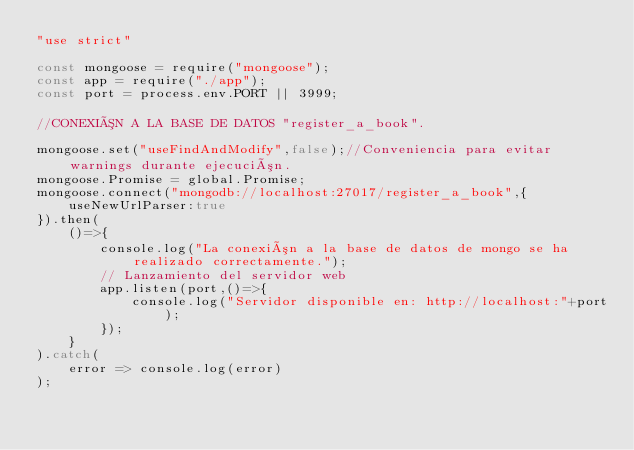Convert code to text. <code><loc_0><loc_0><loc_500><loc_500><_JavaScript_>"use strict"

const mongoose = require("mongoose");
const app = require("./app");
const port = process.env.PORT || 3999;

//CONEXIÓN A LA BASE DE DATOS "register_a_book".

mongoose.set("useFindAndModify",false);//Conveniencia para evitar warnings durante ejecución.
mongoose.Promise = global.Promise;
mongoose.connect("mongodb://localhost:27017/register_a_book",{
    useNewUrlParser:true
}).then(
    ()=>{
        console.log("La conexión a la base de datos de mongo se ha realizado correctamente.");
        // Lanzamiento del servidor web
        app.listen(port,()=>{
            console.log("Servidor disponible en: http://localhost:"+port);
        });
    }
).catch(
    error => console.log(error)
);</code> 